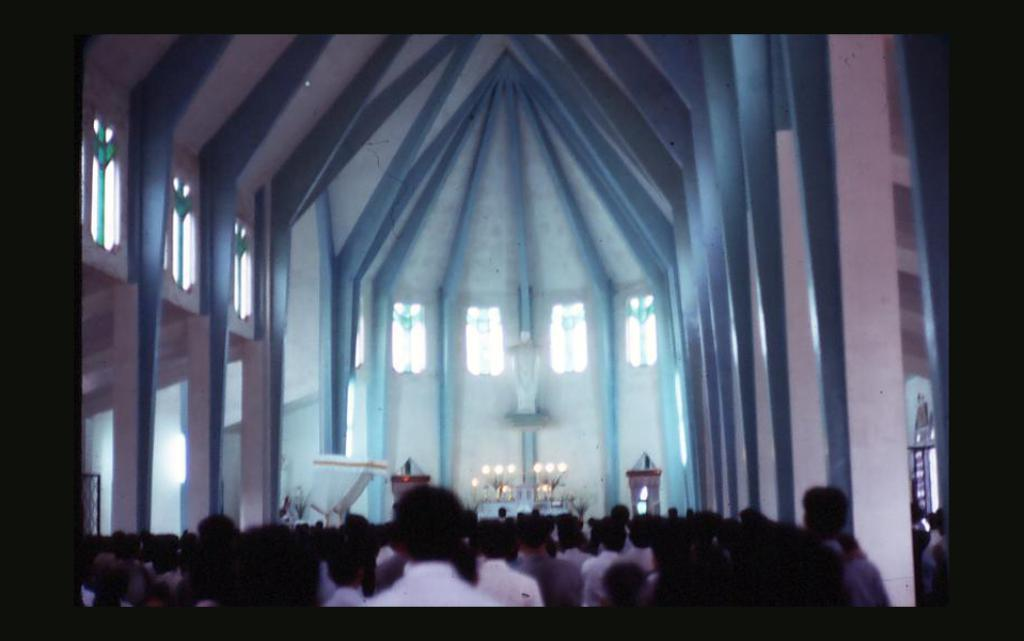What type of view does the image provide? The image provides an inside view of a building. What can be seen in the foreground of the image? There is a group of people in the foreground of the image. What objects are visible in the background of the image? There are candles and windows present in the background of the image. What type of print can be seen on the floor in the image? There is no print visible on the floor in the image. What type of hall is depicted in the image? The image does not depict a hall; it provides an inside view of a building with a group of people, candles, and windows. 